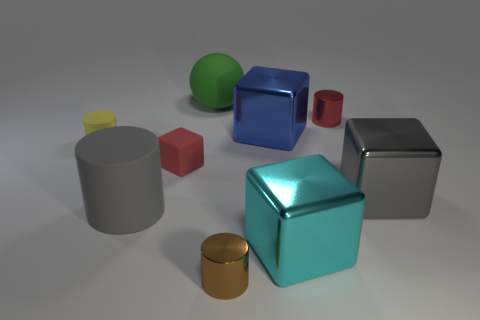Is there any other thing that is the same shape as the green rubber object?
Keep it short and to the point. No. What is the red object behind the small matte cube made of?
Provide a succinct answer. Metal. There is a shiny cube that is left of the cyan cube that is on the right side of the yellow matte object; what size is it?
Provide a succinct answer. Large. What number of yellow cylinders are the same size as the green sphere?
Offer a very short reply. 0. There is a small object on the right side of the brown shiny object; is its color the same as the cube that is on the left side of the big blue shiny cube?
Your answer should be compact. Yes. Are there any big metal objects right of the blue object?
Provide a succinct answer. Yes. What is the color of the small cylinder that is left of the cyan metallic block and on the right side of the yellow cylinder?
Make the answer very short. Brown. Is there a thing that has the same color as the tiny matte block?
Make the answer very short. Yes. Is the red object that is in front of the tiny red metal cylinder made of the same material as the cylinder that is behind the blue metal block?
Your response must be concise. No. There is a metal cube that is right of the small red metal object; what is its size?
Your answer should be compact. Large. 